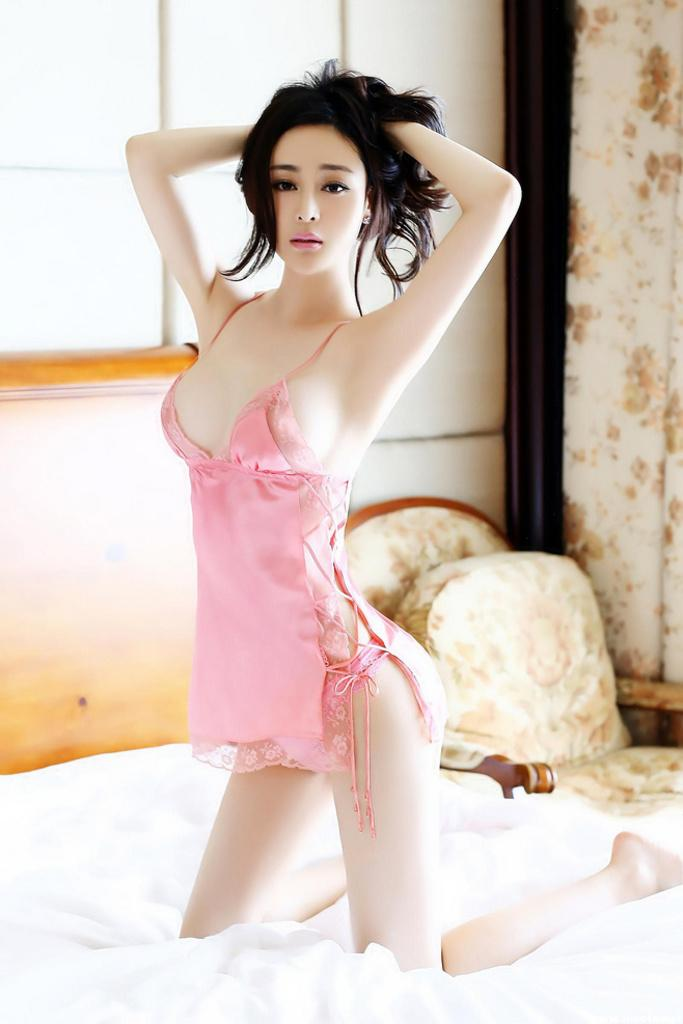Who is present in the image? There is a woman in the image. What is the woman doing in the image? The woman is sewing in the image. What is the woman sitting on in the image? The woman is on a white cloth in the image. What can be seen in the background of the image? There is a wall, a chair, and a curtain in the background of the image. What type of match is the woman using to light the coal in the image? There is no match or coal present in the image; the woman is sewing on a white cloth. What kind of beetle can be seen crawling on the curtain in the image? There is no beetle present in the image; the curtain is part of the background setting. 